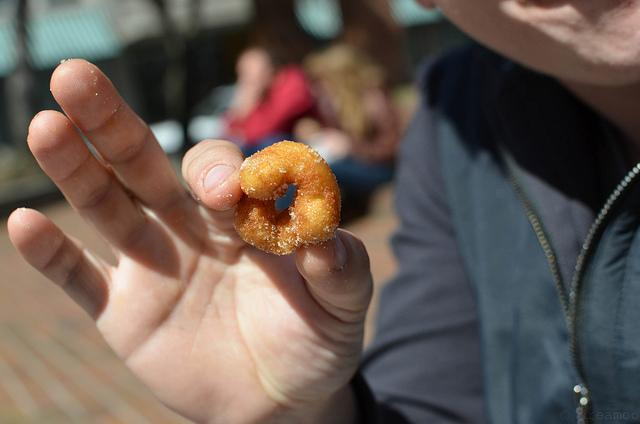What is the man holding? donut 